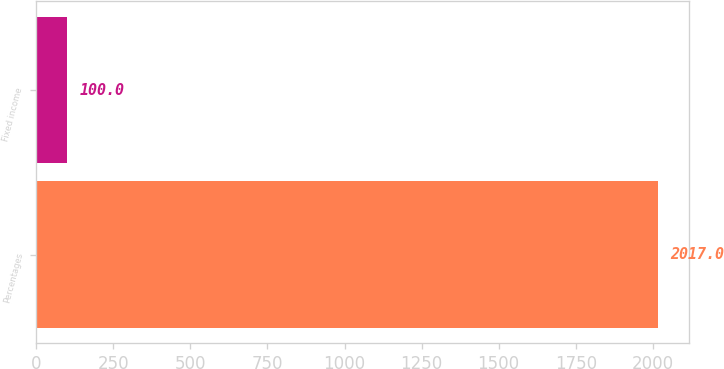Convert chart. <chart><loc_0><loc_0><loc_500><loc_500><bar_chart><fcel>Percentages<fcel>Fixed income<nl><fcel>2017<fcel>100<nl></chart> 